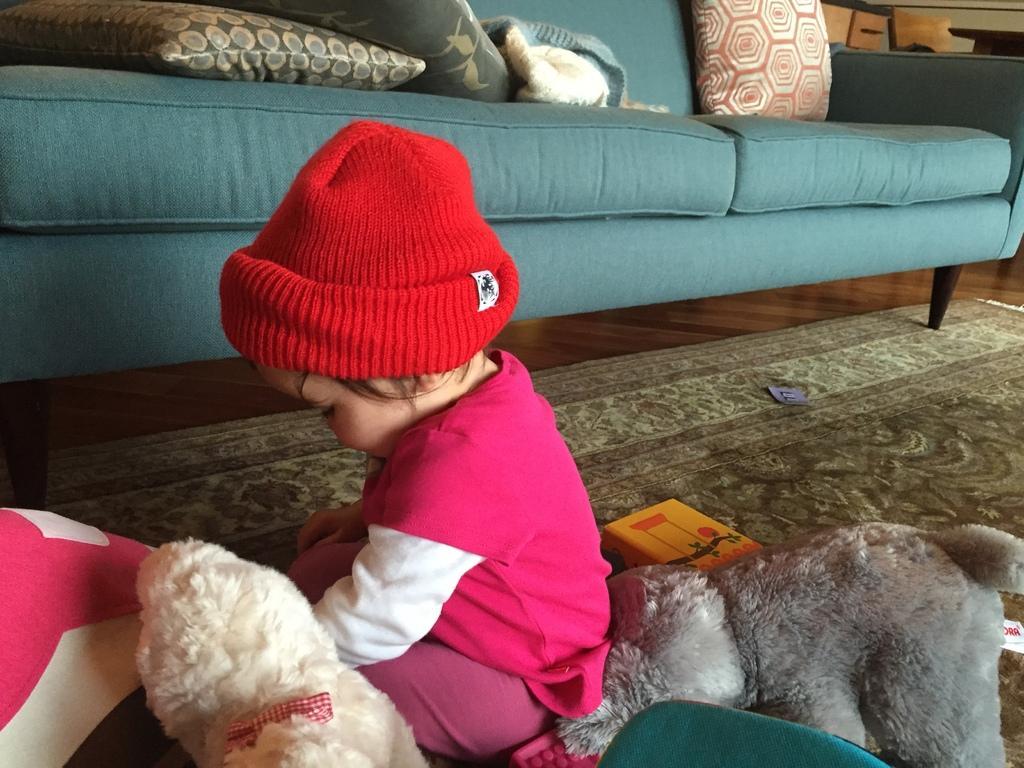Could you give a brief overview of what you see in this image? In this picture we can see a kid with a red cap is sitting on the carpet. On the left and right side of the kid there are toys and behind the kid there are cushions on the couch. On the right side of the couch it looks like a table. 